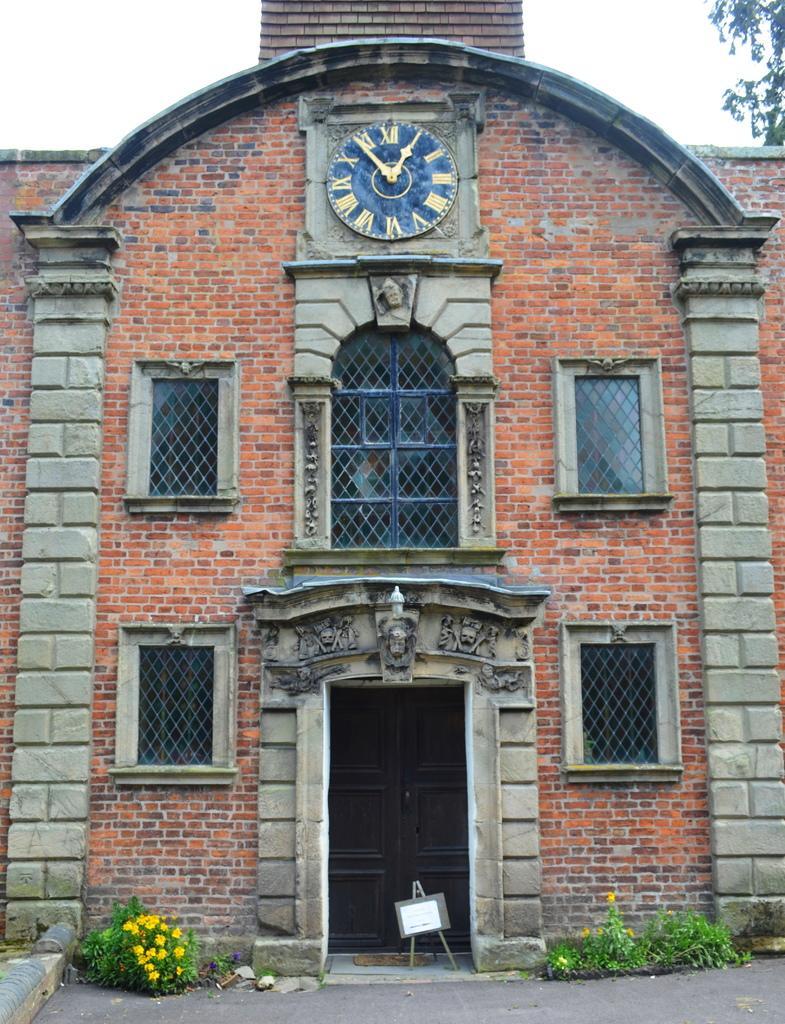In one or two sentences, can you explain what this image depicts? In this image I can see a building with a clock on it. There are flowering plants on either side of this image, at the top it is the sky. 